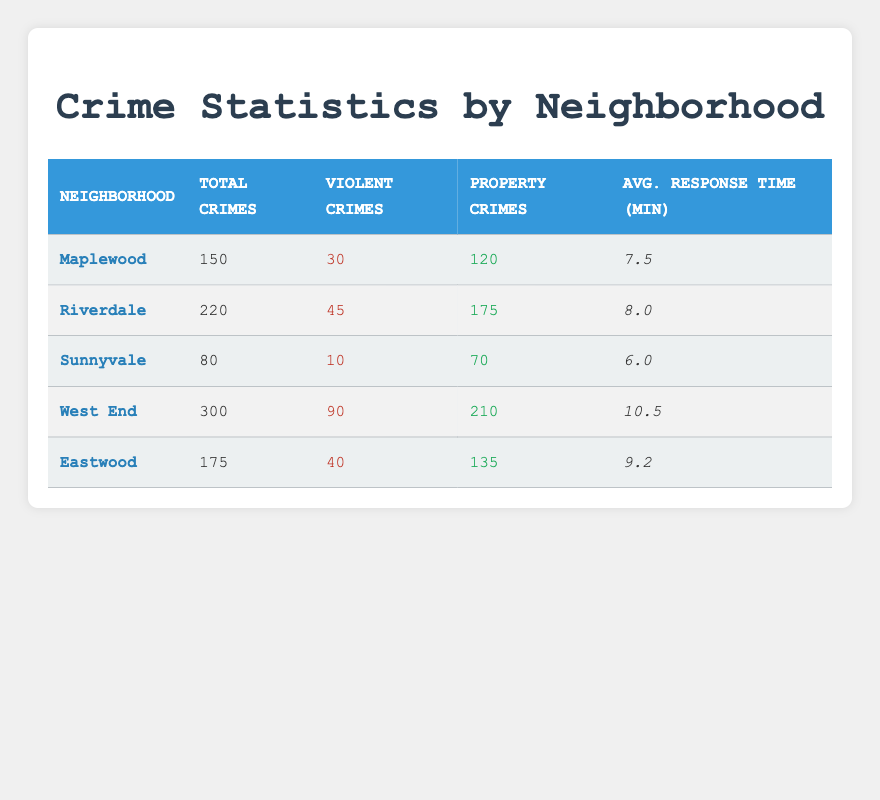What is the total number of crimes in Maplewood? The table shows that Maplewood has 150 total crimes listed in the corresponding cell under the "Total Crimes" column.
Answer: 150 How many violent crimes were reported in Riverdale? According to the table, Riverdale has 45 violent crimes indicated in the "Violent Crimes" column.
Answer: 45 Which neighborhood has the lowest average response time? We can compare the values in the "Avg. Response Time (min)" column and see that Sunnyvale has the lowest response time of 6.0 minutes.
Answer: Sunnyvale What is the total number of property crimes in West End and Eastwood combined? We locate the property crimes for both neighborhoods: West End has 210, and Eastwood has 135. The sum is 210 + 135 = 345.
Answer: 345 Is the average response time in Maplewood faster than in Eastwood? Maplewood has an average response time of 7.5 minutes, while Eastwood has 9.2 minutes. Since 7.5 is less than 9.2, Maplewood is faster.
Answer: Yes What percentage of total crimes in West End were violent crimes? West End has 300 total crimes and 90 violent crimes. The percentage is (90 / 300) * 100 = 30%.
Answer: 30% Which neighborhood has the highest number of property crimes, and what is that number? By looking at the "Property Crimes" column, West End has the highest number with 210 property crimes.
Answer: West End, 210 What is the average response time for all neighborhoods combined? We add the response times: 7.5 + 8.0 + 6.0 + 10.5 + 9.2 = 41.2 minutes. There are 5 neighborhoods, so we divide: 41.2 / 5 = 8.24.
Answer: 8.24 In which neighborhood is the ratio of violent crimes to total crimes the highest? We calculate the ratio for each neighborhood: Maplewood (30/150=0.20), Riverdale (45/220=0.20), Sunnyvale (10/80=0.125), West End (90/300=0.30), Eastwood (40/175=0.229). West End has the highest ratio at 0.30.
Answer: West End How many neighborhoods have more than 200 total crimes? We examine the "Total Crimes" column and find that Riverdale (220) and West End (300) meet this criterion, making a total of 2 neighborhoods.
Answer: 2 